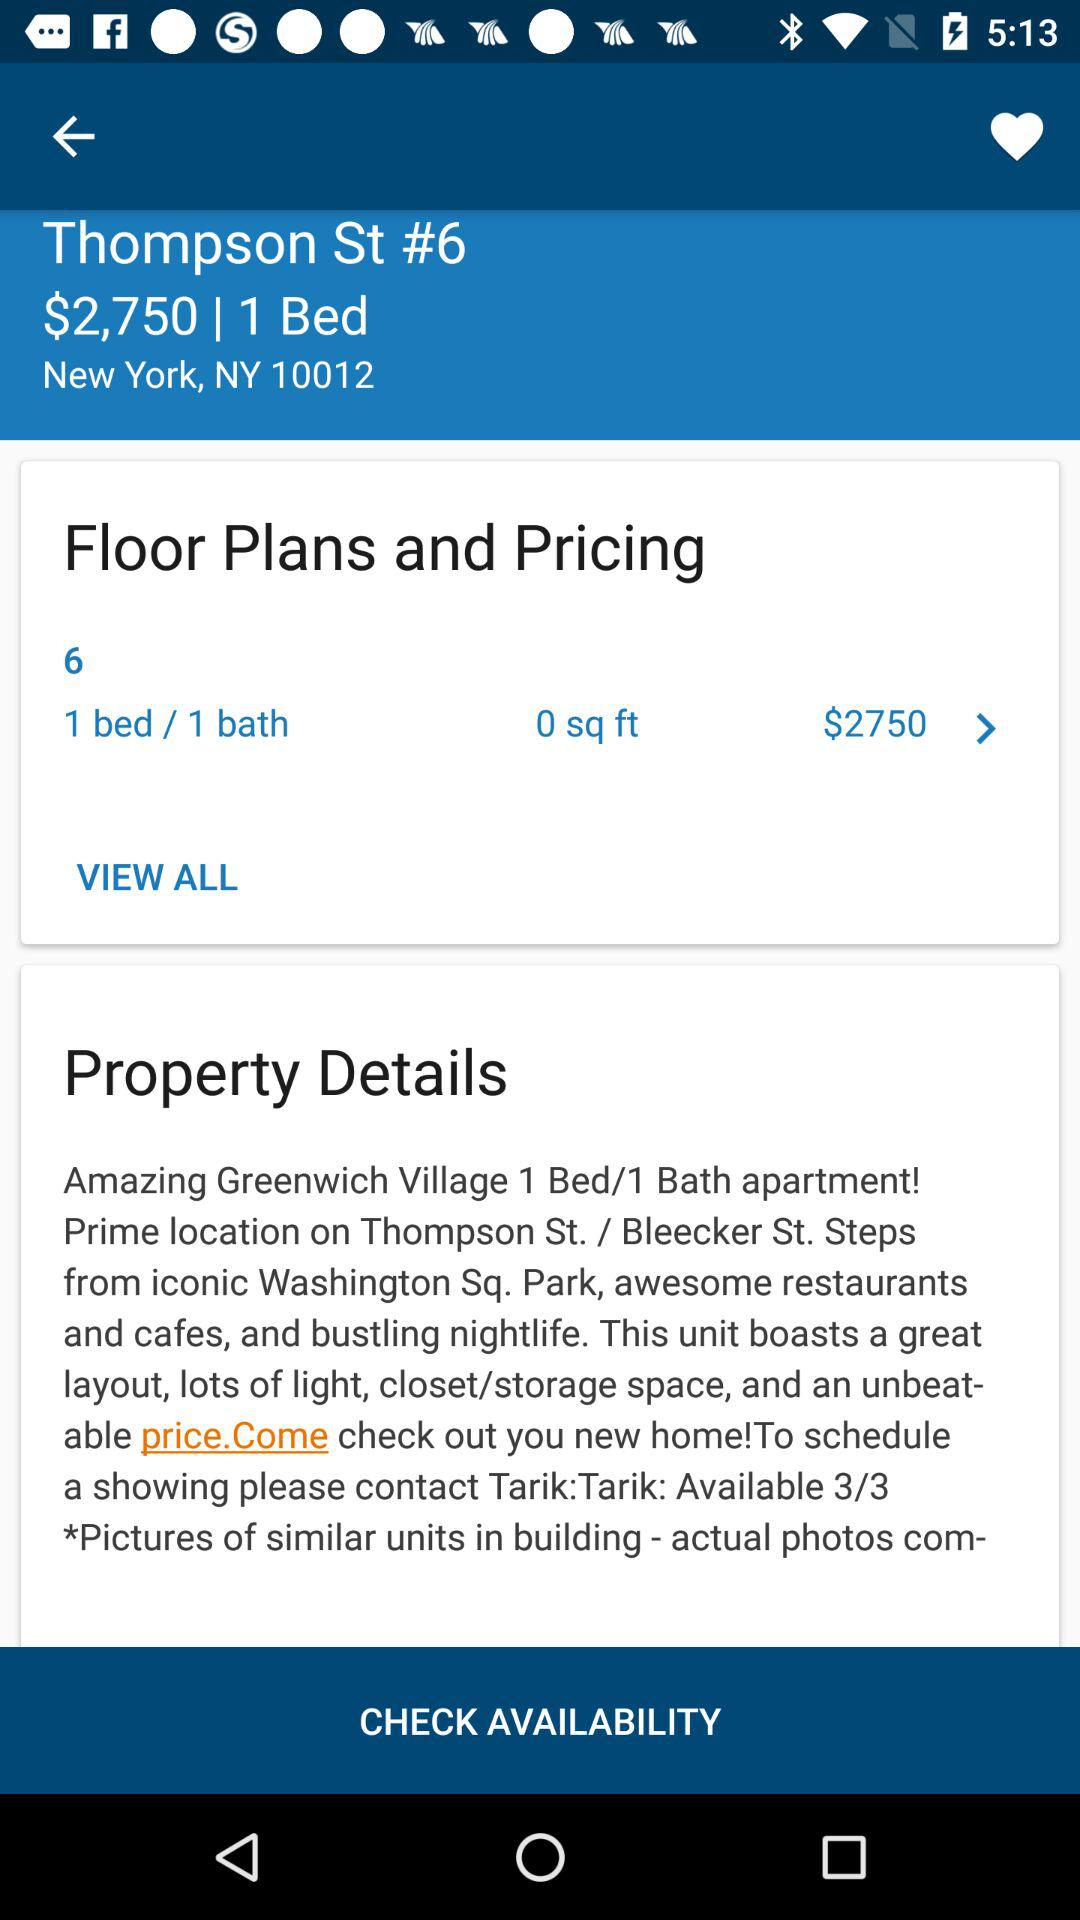What is the mentioned location? The mentioned location is 6 Thompson St., New York, NY 10012. 